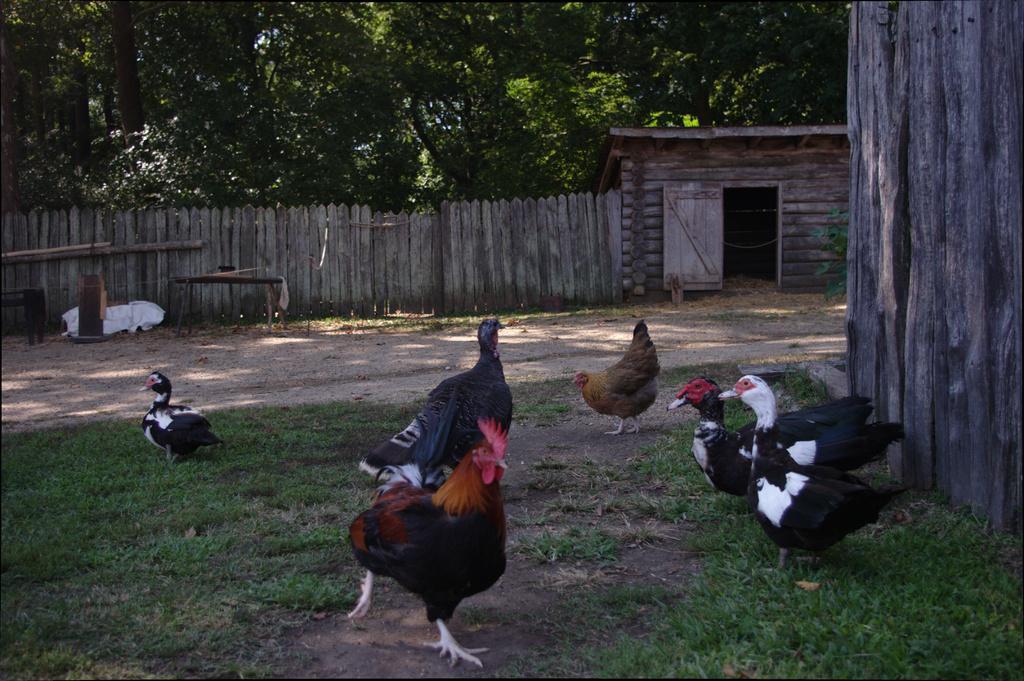Describe this image in one or two sentences. This image is taken outdoors. At the bottom of the image there is a ground with grass on it. In the background there are many trees. On the right side of the image there is a wooden wall. In the middle of the image there is a wooden fence and there is a wooden cabin with a door and a roof. There are few hens on the ground. 